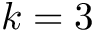<formula> <loc_0><loc_0><loc_500><loc_500>k = 3</formula> 